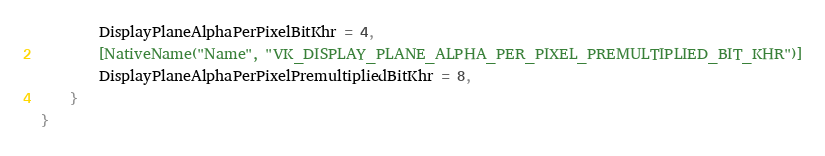Convert code to text. <code><loc_0><loc_0><loc_500><loc_500><_C#_>        DisplayPlaneAlphaPerPixelBitKhr = 4,
        [NativeName("Name", "VK_DISPLAY_PLANE_ALPHA_PER_PIXEL_PREMULTIPLIED_BIT_KHR")]
        DisplayPlaneAlphaPerPixelPremultipliedBitKhr = 8,
    }
}
</code> 